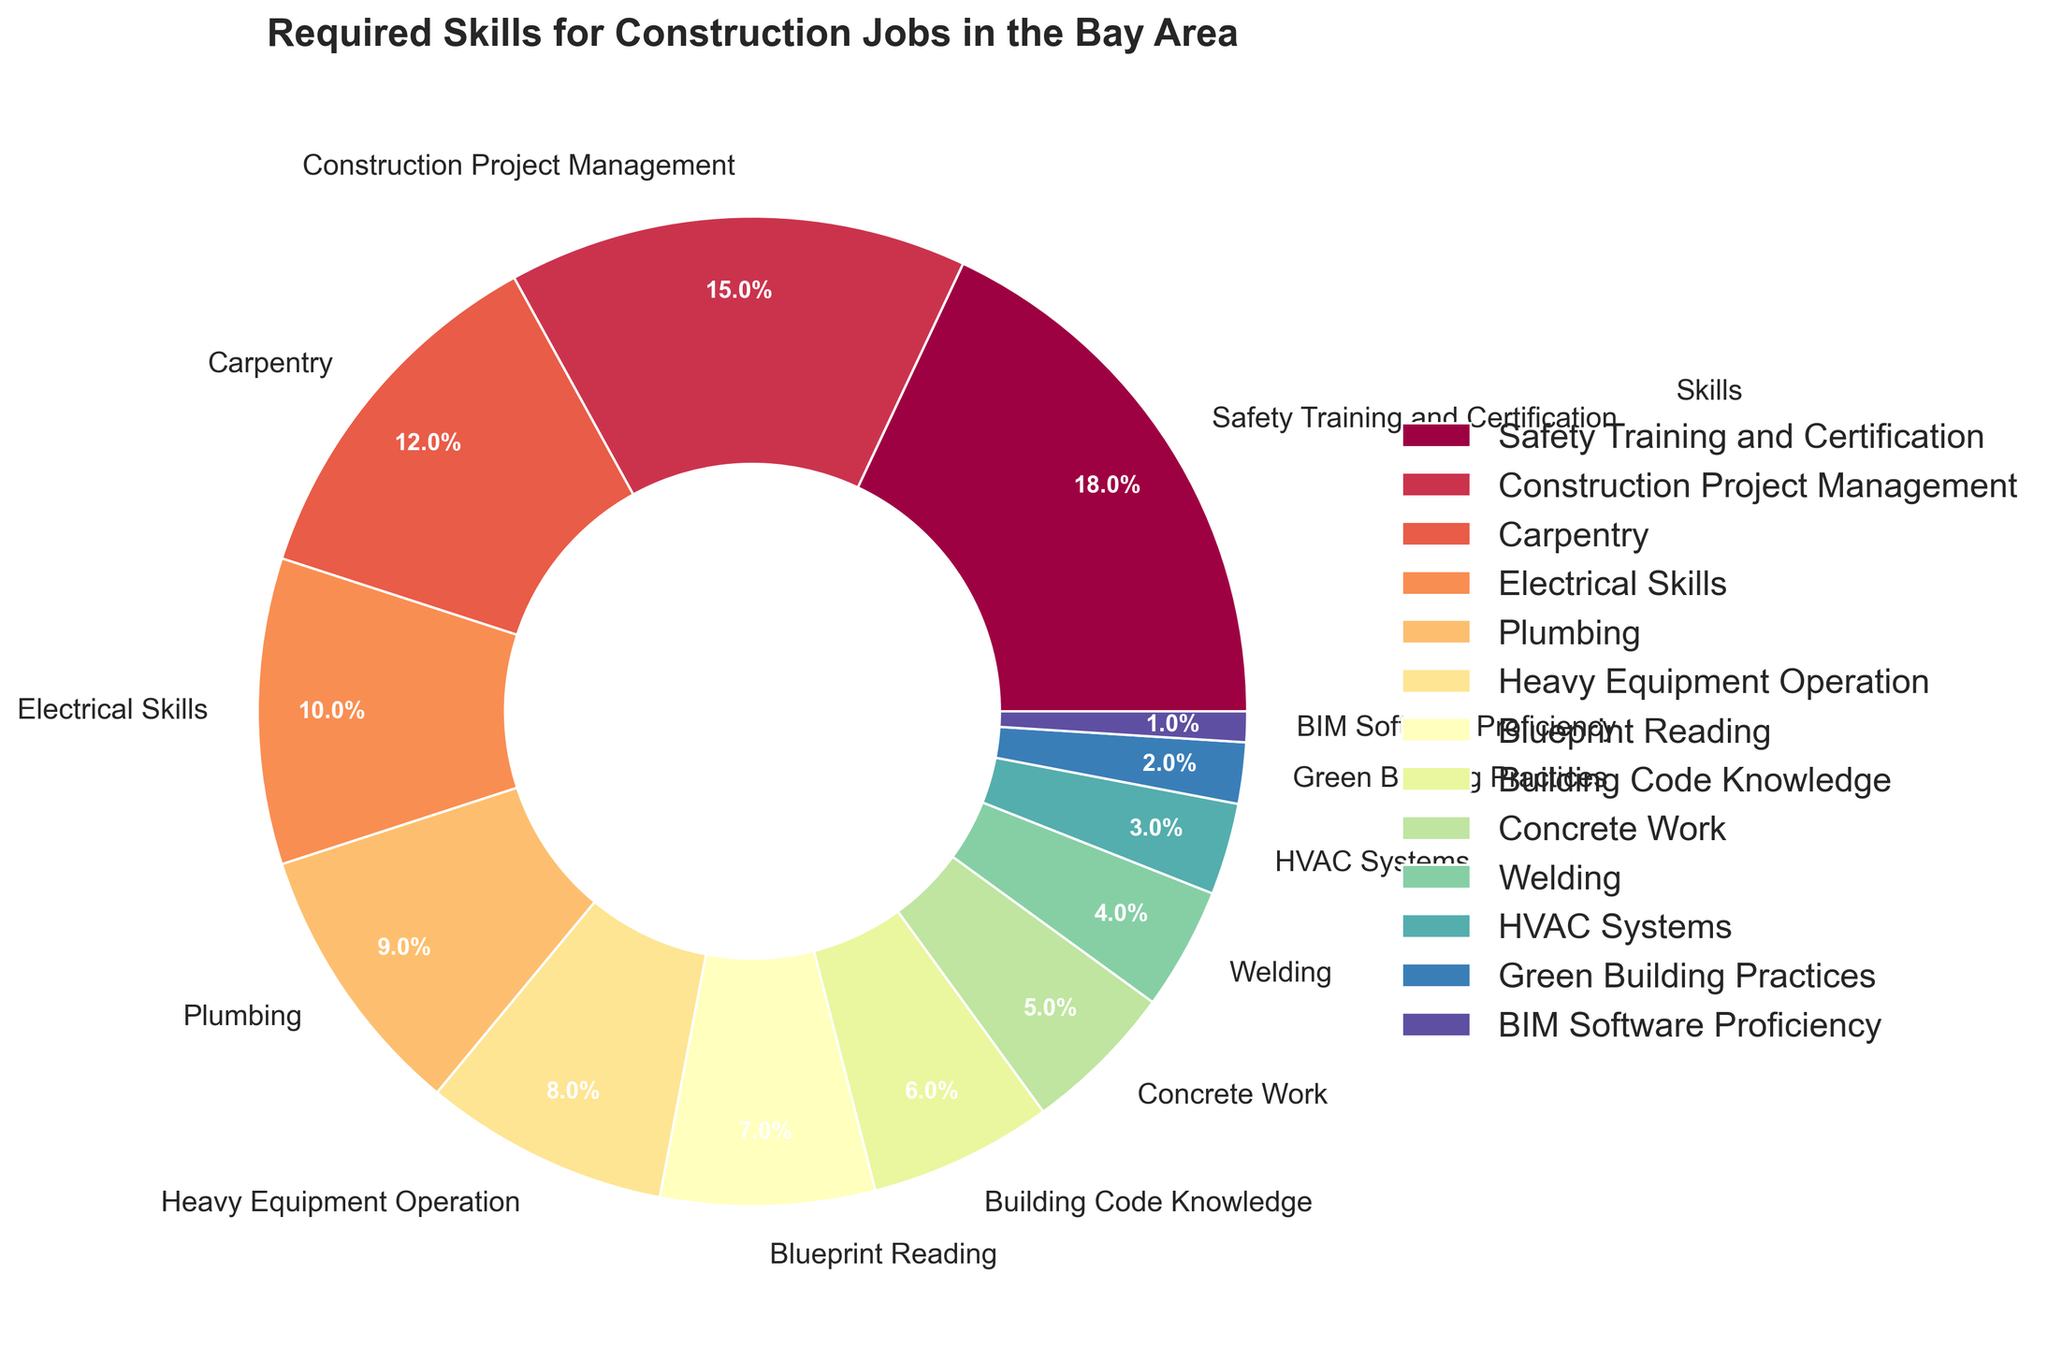Which skill has the highest percentage in the pie chart? Locate the skill with the largest wedge on the pie chart and read its corresponding label.
Answer: Safety Training and Certification Which skills make up more than 50% of the required skills when combined? Look for the largest wedges in the pie chart and sum their percentages. Start with the highest and add until the sum exceeds 50%. (18% + 15% + 12% + 10%)
Answer: Safety Training and Certification, Construction Project Management, Carpentry, Electrical Skills What is the combined percentage of Plumbing and HVAC Systems? Find the segments corresponding to Plumbing and HVAC Systems and add their percentages. (9% + 3%)
Answer: 12% Is the percentage for Welding greater than BIM Software Proficiency? Compare the wedge sizes for Welding and BIM Software Proficiency.
Answer: Yes Which skill is represented by the smallest wedge in the chart? Look for the smallest wedge visually on the pie chart and identify the skill.
Answer: BIM Software Proficiency Do Safety Training and Certification, and Construction Project Management together represent more than one-third of the total skills? Add the percentages of these two skills (18% + 15%) and check if it is greater than 33.33%.
Answer: Yes Which skill area is represented by a green color in the pie chart? Identify the wedge colored green and read its corresponding label.
Answer: This could vary depending on the exact shade and color mapping, so visually confirm based on the provided chart How many skills have a percentage lower than 10%? Count all wedges that represent skills with percentages less than 10%.
Answer: 8 (Plumbing, Heavy Equipment Operation, Blueprint Reading, Building Code Knowledge, Concrete Work, Welding, HVAC Systems, Green Building Practices, BIM Software Proficiency) Is Carpentry less common than Construction Project Management? Compare the percentages of Carpentry and Construction Project Management.
Answer: Yes 